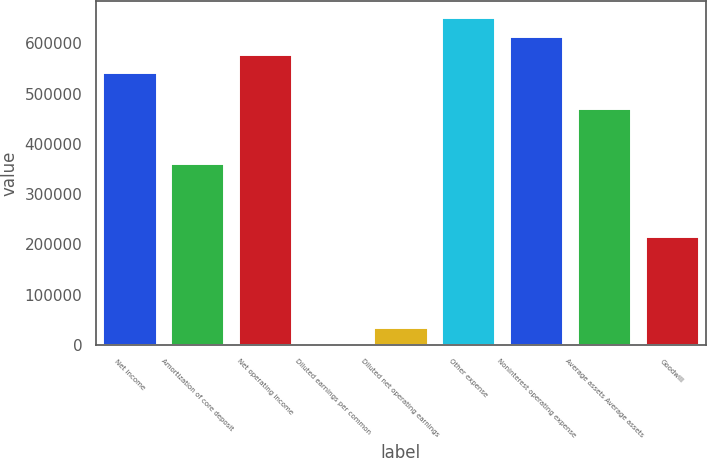Convert chart to OTSL. <chart><loc_0><loc_0><loc_500><loc_500><bar_chart><fcel>Net income<fcel>Amortization of core deposit<fcel>Net operating income<fcel>Diluted earnings per common<fcel>Diluted net operating earnings<fcel>Other expense<fcel>Noninterest operating expense<fcel>Average assets Average assets<fcel>Goodwill<nl><fcel>542882<fcel>361922<fcel>579074<fcel>1.62<fcel>36193.7<fcel>651458<fcel>615266<fcel>470498<fcel>217154<nl></chart> 